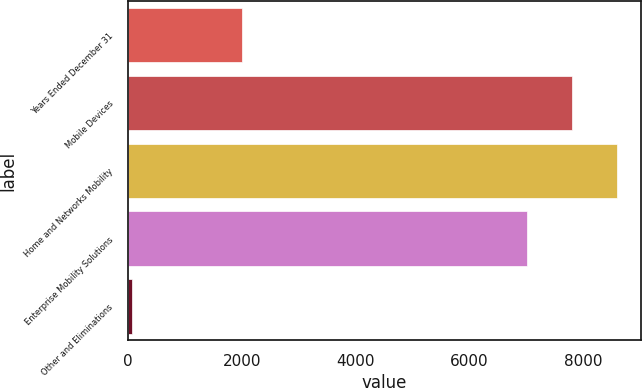<chart> <loc_0><loc_0><loc_500><loc_500><bar_chart><fcel>Years Ended December 31<fcel>Mobile Devices<fcel>Home and Networks Mobility<fcel>Enterprise Mobility Solutions<fcel>Other and Eliminations<nl><fcel>2009<fcel>7797<fcel>8586<fcel>7008<fcel>73<nl></chart> 